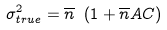Convert formula to latex. <formula><loc_0><loc_0><loc_500><loc_500>\sigma _ { t r u e } ^ { 2 } = \overline { n } \ ( 1 + \overline { n } A C )</formula> 